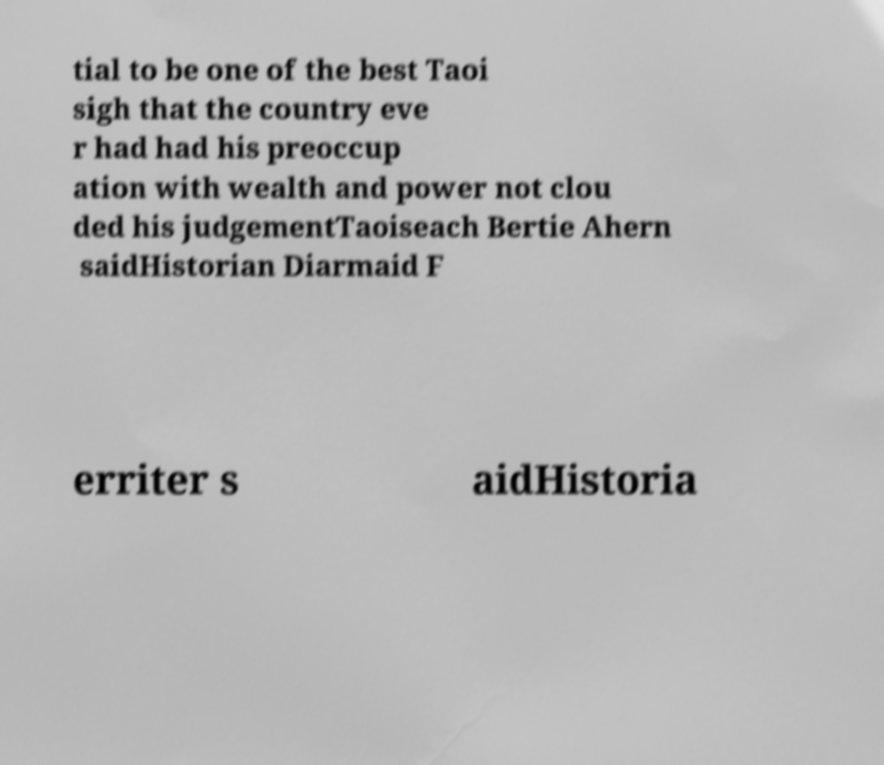I need the written content from this picture converted into text. Can you do that? tial to be one of the best Taoi sigh that the country eve r had had his preoccup ation with wealth and power not clou ded his judgementTaoiseach Bertie Ahern saidHistorian Diarmaid F erriter s aidHistoria 